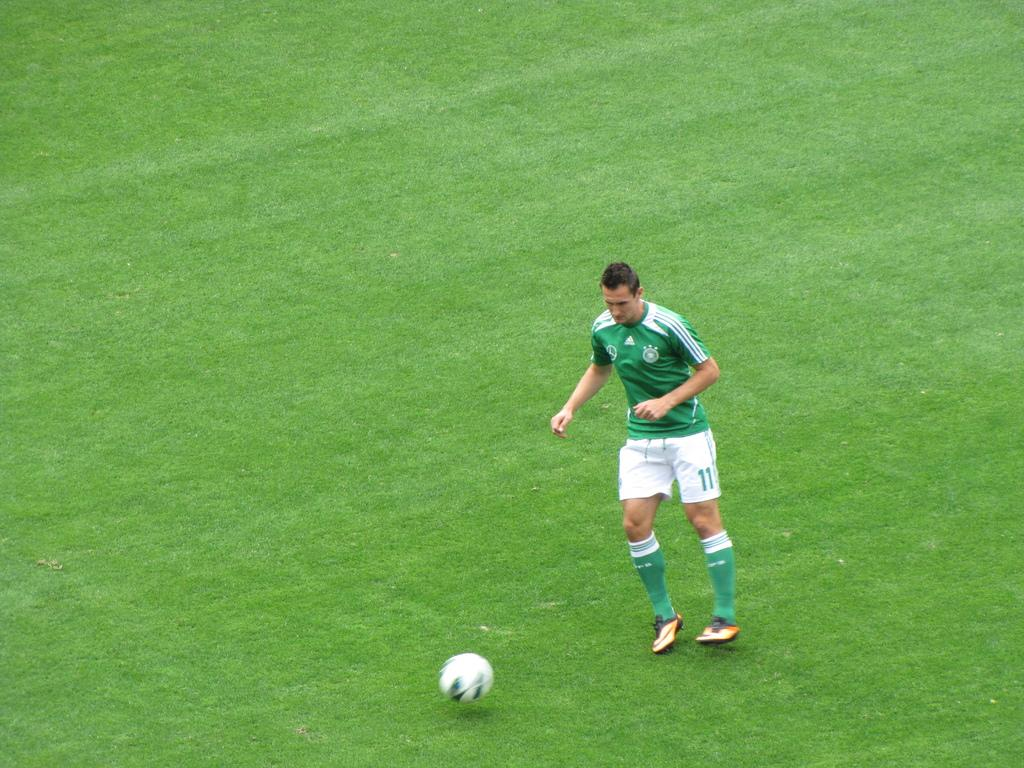<image>
Describe the image concisely. A soccer players has the number 11 on his shorts. 